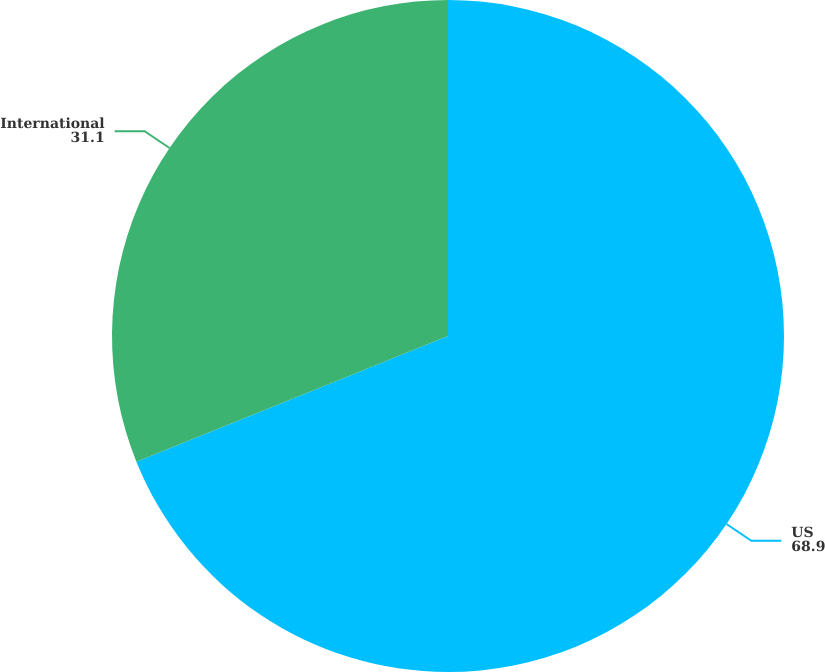<chart> <loc_0><loc_0><loc_500><loc_500><pie_chart><fcel>US<fcel>International<nl><fcel>68.9%<fcel>31.1%<nl></chart> 